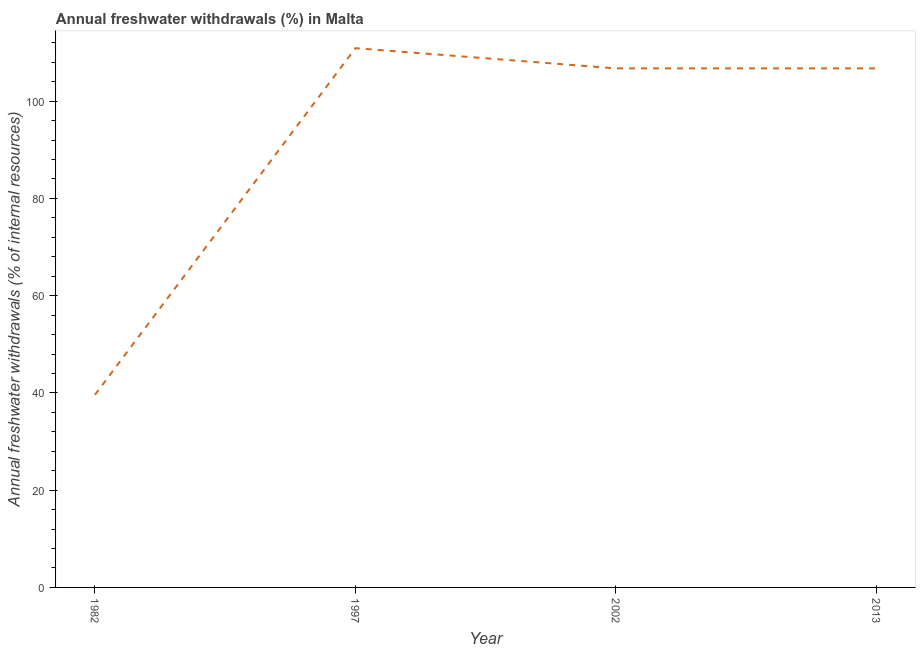What is the annual freshwater withdrawals in 1982?
Provide a succinct answer. 39.6. Across all years, what is the maximum annual freshwater withdrawals?
Provide a short and direct response. 110.89. Across all years, what is the minimum annual freshwater withdrawals?
Provide a succinct answer. 39.6. What is the sum of the annual freshwater withdrawals?
Ensure brevity in your answer.  363.96. What is the difference between the annual freshwater withdrawals in 1982 and 1997?
Your answer should be very brief. -71.29. What is the average annual freshwater withdrawals per year?
Give a very brief answer. 90.99. What is the median annual freshwater withdrawals?
Your answer should be compact. 106.73. In how many years, is the annual freshwater withdrawals greater than 12 %?
Your answer should be very brief. 4. What is the ratio of the annual freshwater withdrawals in 1997 to that in 2002?
Offer a very short reply. 1.04. What is the difference between the highest and the second highest annual freshwater withdrawals?
Keep it short and to the point. 4.16. What is the difference between the highest and the lowest annual freshwater withdrawals?
Provide a succinct answer. 71.29. In how many years, is the annual freshwater withdrawals greater than the average annual freshwater withdrawals taken over all years?
Offer a terse response. 3. Does the annual freshwater withdrawals monotonically increase over the years?
Keep it short and to the point. No. How many lines are there?
Provide a short and direct response. 1. How many years are there in the graph?
Make the answer very short. 4. What is the difference between two consecutive major ticks on the Y-axis?
Ensure brevity in your answer.  20. Does the graph contain grids?
Give a very brief answer. No. What is the title of the graph?
Make the answer very short. Annual freshwater withdrawals (%) in Malta. What is the label or title of the X-axis?
Your response must be concise. Year. What is the label or title of the Y-axis?
Make the answer very short. Annual freshwater withdrawals (% of internal resources). What is the Annual freshwater withdrawals (% of internal resources) of 1982?
Your response must be concise. 39.6. What is the Annual freshwater withdrawals (% of internal resources) in 1997?
Your response must be concise. 110.89. What is the Annual freshwater withdrawals (% of internal resources) in 2002?
Keep it short and to the point. 106.73. What is the Annual freshwater withdrawals (% of internal resources) in 2013?
Offer a very short reply. 106.73. What is the difference between the Annual freshwater withdrawals (% of internal resources) in 1982 and 1997?
Ensure brevity in your answer.  -71.29. What is the difference between the Annual freshwater withdrawals (% of internal resources) in 1982 and 2002?
Keep it short and to the point. -67.13. What is the difference between the Annual freshwater withdrawals (% of internal resources) in 1982 and 2013?
Make the answer very short. -67.13. What is the difference between the Annual freshwater withdrawals (% of internal resources) in 1997 and 2002?
Offer a very short reply. 4.16. What is the difference between the Annual freshwater withdrawals (% of internal resources) in 1997 and 2013?
Offer a terse response. 4.16. What is the ratio of the Annual freshwater withdrawals (% of internal resources) in 1982 to that in 1997?
Provide a succinct answer. 0.36. What is the ratio of the Annual freshwater withdrawals (% of internal resources) in 1982 to that in 2002?
Your answer should be very brief. 0.37. What is the ratio of the Annual freshwater withdrawals (% of internal resources) in 1982 to that in 2013?
Offer a very short reply. 0.37. What is the ratio of the Annual freshwater withdrawals (% of internal resources) in 1997 to that in 2002?
Provide a succinct answer. 1.04. What is the ratio of the Annual freshwater withdrawals (% of internal resources) in 1997 to that in 2013?
Provide a succinct answer. 1.04. What is the ratio of the Annual freshwater withdrawals (% of internal resources) in 2002 to that in 2013?
Make the answer very short. 1. 